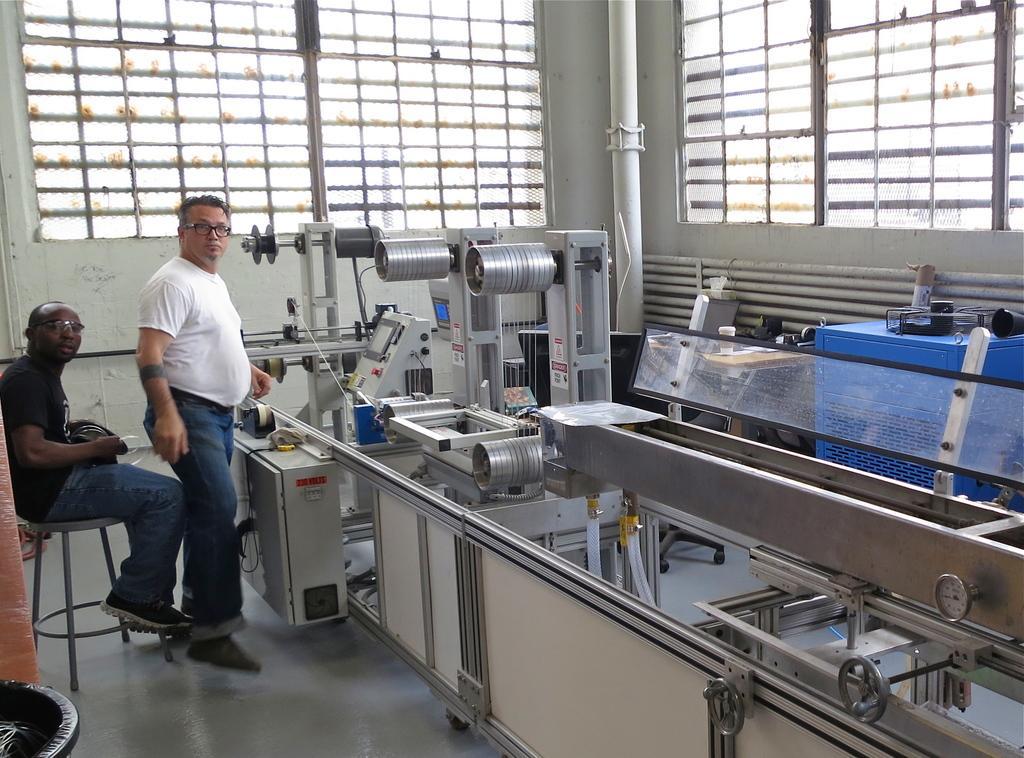Describe this image in one or two sentences. In the picture we can see two men, one man is sitting on a stool and one man is standing and we can see a missionary, a two men are wearing black and white T-shirts, with blue jeans and shoes, in the background we can find a wall with pipe. 